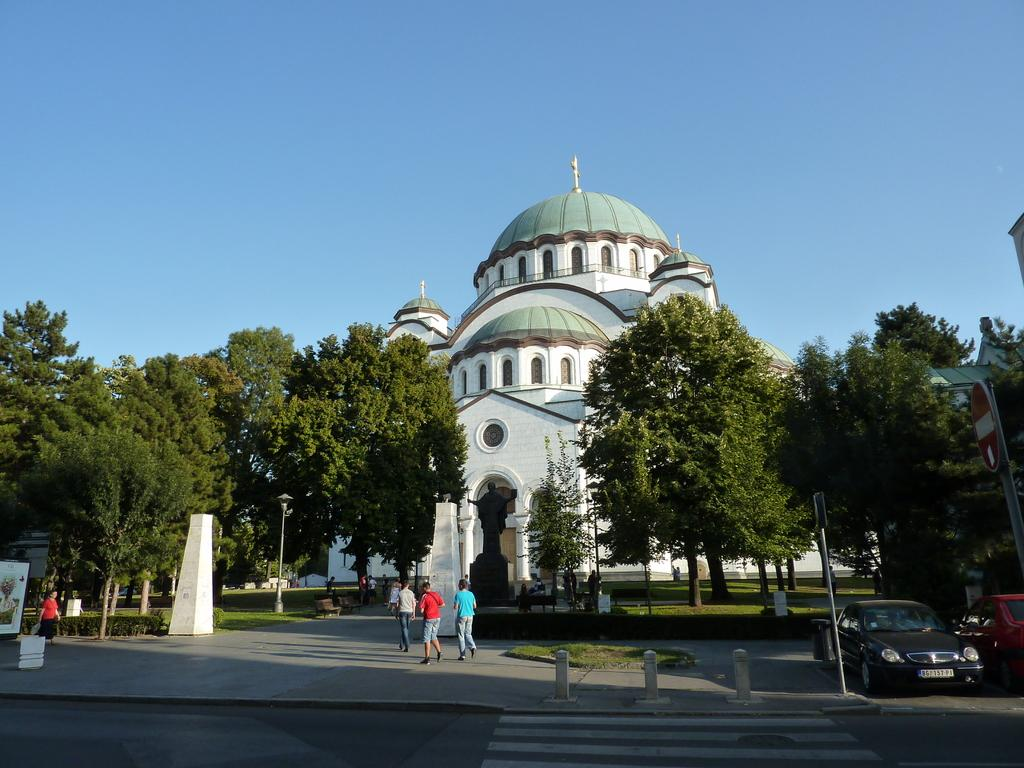What type of structure is present in the image? There is a building in the image. What natural elements are surrounding the building? There are trees around the building. Are there any other types of vegetation in the image? Yes, there are plants in the image. Can you describe the people in the image? There are people in the image. What else is visible in the image besides the building, trees, plants, and people? There are cars in the image. What type of kitty can be seen interacting with the strangers in the image? There is no kitty or stranger present in the image. What is the mass of the building in the image? The mass of the building cannot be determined from the image alone. 